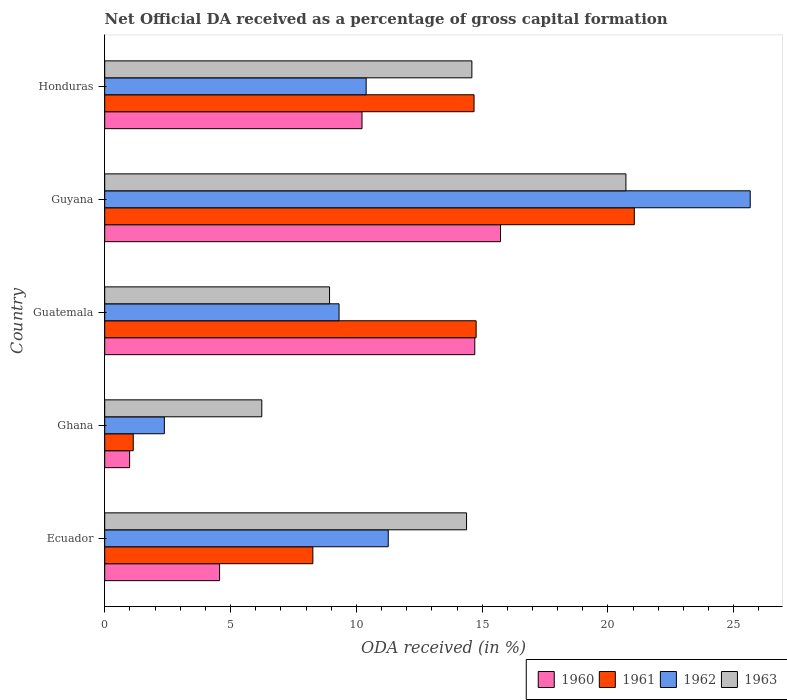How many different coloured bars are there?
Provide a short and direct response. 4. How many groups of bars are there?
Offer a very short reply. 5. Are the number of bars on each tick of the Y-axis equal?
Give a very brief answer. Yes. What is the label of the 3rd group of bars from the top?
Ensure brevity in your answer.  Guatemala. What is the net ODA received in 1961 in Ghana?
Offer a terse response. 1.13. Across all countries, what is the maximum net ODA received in 1962?
Offer a terse response. 25.65. Across all countries, what is the minimum net ODA received in 1961?
Ensure brevity in your answer.  1.13. In which country was the net ODA received in 1961 maximum?
Keep it short and to the point. Guyana. What is the total net ODA received in 1961 in the graph?
Keep it short and to the point. 59.89. What is the difference between the net ODA received in 1962 in Guatemala and that in Guyana?
Offer a terse response. -16.34. What is the difference between the net ODA received in 1963 in Guyana and the net ODA received in 1962 in Guatemala?
Your answer should be compact. 11.4. What is the average net ODA received in 1961 per country?
Offer a very short reply. 11.98. What is the difference between the net ODA received in 1963 and net ODA received in 1961 in Guatemala?
Keep it short and to the point. -5.83. What is the ratio of the net ODA received in 1960 in Ecuador to that in Ghana?
Your answer should be compact. 4.61. Is the net ODA received in 1960 in Ghana less than that in Guatemala?
Your answer should be compact. Yes. What is the difference between the highest and the second highest net ODA received in 1962?
Ensure brevity in your answer.  14.39. What is the difference between the highest and the lowest net ODA received in 1961?
Your response must be concise. 19.91. In how many countries, is the net ODA received in 1963 greater than the average net ODA received in 1963 taken over all countries?
Ensure brevity in your answer.  3. Is it the case that in every country, the sum of the net ODA received in 1963 and net ODA received in 1962 is greater than the sum of net ODA received in 1960 and net ODA received in 1961?
Provide a short and direct response. No. What does the 4th bar from the top in Ghana represents?
Offer a terse response. 1960. What does the 2nd bar from the bottom in Honduras represents?
Provide a succinct answer. 1961. Is it the case that in every country, the sum of the net ODA received in 1962 and net ODA received in 1960 is greater than the net ODA received in 1961?
Give a very brief answer. Yes. How many bars are there?
Make the answer very short. 20. Are all the bars in the graph horizontal?
Make the answer very short. Yes. What is the difference between two consecutive major ticks on the X-axis?
Keep it short and to the point. 5. How many legend labels are there?
Provide a short and direct response. 4. How are the legend labels stacked?
Your answer should be very brief. Horizontal. What is the title of the graph?
Offer a very short reply. Net Official DA received as a percentage of gross capital formation. Does "1988" appear as one of the legend labels in the graph?
Your response must be concise. No. What is the label or title of the X-axis?
Offer a terse response. ODA received (in %). What is the label or title of the Y-axis?
Your answer should be compact. Country. What is the ODA received (in %) in 1960 in Ecuador?
Make the answer very short. 4.56. What is the ODA received (in %) in 1961 in Ecuador?
Provide a short and direct response. 8.27. What is the ODA received (in %) in 1962 in Ecuador?
Your answer should be very brief. 11.27. What is the ODA received (in %) of 1963 in Ecuador?
Offer a terse response. 14.38. What is the ODA received (in %) in 1960 in Ghana?
Provide a succinct answer. 0.99. What is the ODA received (in %) in 1961 in Ghana?
Your answer should be very brief. 1.13. What is the ODA received (in %) in 1962 in Ghana?
Provide a short and direct response. 2.37. What is the ODA received (in %) of 1963 in Ghana?
Your answer should be compact. 6.24. What is the ODA received (in %) in 1960 in Guatemala?
Your answer should be compact. 14.71. What is the ODA received (in %) of 1961 in Guatemala?
Give a very brief answer. 14.76. What is the ODA received (in %) of 1962 in Guatemala?
Provide a succinct answer. 9.31. What is the ODA received (in %) in 1963 in Guatemala?
Provide a short and direct response. 8.93. What is the ODA received (in %) in 1960 in Guyana?
Offer a terse response. 15.73. What is the ODA received (in %) of 1961 in Guyana?
Your answer should be very brief. 21.05. What is the ODA received (in %) in 1962 in Guyana?
Your response must be concise. 25.65. What is the ODA received (in %) of 1963 in Guyana?
Provide a succinct answer. 20.71. What is the ODA received (in %) in 1960 in Honduras?
Keep it short and to the point. 10.23. What is the ODA received (in %) in 1961 in Honduras?
Provide a succinct answer. 14.68. What is the ODA received (in %) in 1962 in Honduras?
Offer a terse response. 10.39. What is the ODA received (in %) in 1963 in Honduras?
Provide a short and direct response. 14.59. Across all countries, what is the maximum ODA received (in %) of 1960?
Provide a short and direct response. 15.73. Across all countries, what is the maximum ODA received (in %) of 1961?
Make the answer very short. 21.05. Across all countries, what is the maximum ODA received (in %) of 1962?
Give a very brief answer. 25.65. Across all countries, what is the maximum ODA received (in %) of 1963?
Make the answer very short. 20.71. Across all countries, what is the minimum ODA received (in %) in 1960?
Offer a terse response. 0.99. Across all countries, what is the minimum ODA received (in %) in 1961?
Your answer should be compact. 1.13. Across all countries, what is the minimum ODA received (in %) of 1962?
Provide a short and direct response. 2.37. Across all countries, what is the minimum ODA received (in %) of 1963?
Make the answer very short. 6.24. What is the total ODA received (in %) of 1960 in the graph?
Provide a short and direct response. 46.22. What is the total ODA received (in %) of 1961 in the graph?
Offer a very short reply. 59.89. What is the total ODA received (in %) in 1962 in the graph?
Make the answer very short. 58.99. What is the total ODA received (in %) of 1963 in the graph?
Make the answer very short. 64.86. What is the difference between the ODA received (in %) in 1960 in Ecuador and that in Ghana?
Provide a succinct answer. 3.57. What is the difference between the ODA received (in %) of 1961 in Ecuador and that in Ghana?
Provide a succinct answer. 7.14. What is the difference between the ODA received (in %) of 1962 in Ecuador and that in Ghana?
Make the answer very short. 8.9. What is the difference between the ODA received (in %) of 1963 in Ecuador and that in Ghana?
Offer a very short reply. 8.14. What is the difference between the ODA received (in %) in 1960 in Ecuador and that in Guatemala?
Give a very brief answer. -10.14. What is the difference between the ODA received (in %) of 1961 in Ecuador and that in Guatemala?
Provide a short and direct response. -6.49. What is the difference between the ODA received (in %) in 1962 in Ecuador and that in Guatemala?
Your answer should be very brief. 1.95. What is the difference between the ODA received (in %) of 1963 in Ecuador and that in Guatemala?
Your answer should be compact. 5.44. What is the difference between the ODA received (in %) of 1960 in Ecuador and that in Guyana?
Your response must be concise. -11.17. What is the difference between the ODA received (in %) in 1961 in Ecuador and that in Guyana?
Ensure brevity in your answer.  -12.78. What is the difference between the ODA received (in %) in 1962 in Ecuador and that in Guyana?
Keep it short and to the point. -14.39. What is the difference between the ODA received (in %) of 1963 in Ecuador and that in Guyana?
Your answer should be very brief. -6.33. What is the difference between the ODA received (in %) in 1960 in Ecuador and that in Honduras?
Ensure brevity in your answer.  -5.66. What is the difference between the ODA received (in %) in 1961 in Ecuador and that in Honduras?
Ensure brevity in your answer.  -6.41. What is the difference between the ODA received (in %) in 1962 in Ecuador and that in Honduras?
Give a very brief answer. 0.88. What is the difference between the ODA received (in %) of 1963 in Ecuador and that in Honduras?
Offer a very short reply. -0.21. What is the difference between the ODA received (in %) in 1960 in Ghana and that in Guatemala?
Provide a succinct answer. -13.72. What is the difference between the ODA received (in %) of 1961 in Ghana and that in Guatemala?
Provide a short and direct response. -13.63. What is the difference between the ODA received (in %) in 1962 in Ghana and that in Guatemala?
Provide a succinct answer. -6.94. What is the difference between the ODA received (in %) in 1963 in Ghana and that in Guatemala?
Give a very brief answer. -2.69. What is the difference between the ODA received (in %) in 1960 in Ghana and that in Guyana?
Ensure brevity in your answer.  -14.74. What is the difference between the ODA received (in %) in 1961 in Ghana and that in Guyana?
Make the answer very short. -19.91. What is the difference between the ODA received (in %) in 1962 in Ghana and that in Guyana?
Offer a very short reply. -23.28. What is the difference between the ODA received (in %) in 1963 in Ghana and that in Guyana?
Your answer should be very brief. -14.47. What is the difference between the ODA received (in %) in 1960 in Ghana and that in Honduras?
Offer a very short reply. -9.23. What is the difference between the ODA received (in %) in 1961 in Ghana and that in Honduras?
Your answer should be compact. -13.54. What is the difference between the ODA received (in %) of 1962 in Ghana and that in Honduras?
Your response must be concise. -8.02. What is the difference between the ODA received (in %) of 1963 in Ghana and that in Honduras?
Ensure brevity in your answer.  -8.35. What is the difference between the ODA received (in %) of 1960 in Guatemala and that in Guyana?
Offer a very short reply. -1.02. What is the difference between the ODA received (in %) in 1961 in Guatemala and that in Guyana?
Offer a terse response. -6.29. What is the difference between the ODA received (in %) in 1962 in Guatemala and that in Guyana?
Offer a very short reply. -16.34. What is the difference between the ODA received (in %) in 1963 in Guatemala and that in Guyana?
Your response must be concise. -11.78. What is the difference between the ODA received (in %) of 1960 in Guatemala and that in Honduras?
Your answer should be very brief. 4.48. What is the difference between the ODA received (in %) in 1961 in Guatemala and that in Honduras?
Make the answer very short. 0.08. What is the difference between the ODA received (in %) of 1962 in Guatemala and that in Honduras?
Ensure brevity in your answer.  -1.08. What is the difference between the ODA received (in %) of 1963 in Guatemala and that in Honduras?
Make the answer very short. -5.66. What is the difference between the ODA received (in %) of 1960 in Guyana and that in Honduras?
Keep it short and to the point. 5.5. What is the difference between the ODA received (in %) of 1961 in Guyana and that in Honduras?
Provide a succinct answer. 6.37. What is the difference between the ODA received (in %) of 1962 in Guyana and that in Honduras?
Provide a succinct answer. 15.26. What is the difference between the ODA received (in %) in 1963 in Guyana and that in Honduras?
Keep it short and to the point. 6.12. What is the difference between the ODA received (in %) in 1960 in Ecuador and the ODA received (in %) in 1961 in Ghana?
Offer a very short reply. 3.43. What is the difference between the ODA received (in %) of 1960 in Ecuador and the ODA received (in %) of 1962 in Ghana?
Your response must be concise. 2.19. What is the difference between the ODA received (in %) of 1960 in Ecuador and the ODA received (in %) of 1963 in Ghana?
Offer a very short reply. -1.68. What is the difference between the ODA received (in %) of 1961 in Ecuador and the ODA received (in %) of 1962 in Ghana?
Offer a very short reply. 5.9. What is the difference between the ODA received (in %) in 1961 in Ecuador and the ODA received (in %) in 1963 in Ghana?
Give a very brief answer. 2.03. What is the difference between the ODA received (in %) of 1962 in Ecuador and the ODA received (in %) of 1963 in Ghana?
Give a very brief answer. 5.03. What is the difference between the ODA received (in %) of 1960 in Ecuador and the ODA received (in %) of 1961 in Guatemala?
Offer a very short reply. -10.2. What is the difference between the ODA received (in %) of 1960 in Ecuador and the ODA received (in %) of 1962 in Guatemala?
Keep it short and to the point. -4.75. What is the difference between the ODA received (in %) of 1960 in Ecuador and the ODA received (in %) of 1963 in Guatemala?
Provide a succinct answer. -4.37. What is the difference between the ODA received (in %) in 1961 in Ecuador and the ODA received (in %) in 1962 in Guatemala?
Offer a terse response. -1.04. What is the difference between the ODA received (in %) of 1961 in Ecuador and the ODA received (in %) of 1963 in Guatemala?
Your response must be concise. -0.66. What is the difference between the ODA received (in %) in 1962 in Ecuador and the ODA received (in %) in 1963 in Guatemala?
Offer a terse response. 2.33. What is the difference between the ODA received (in %) in 1960 in Ecuador and the ODA received (in %) in 1961 in Guyana?
Ensure brevity in your answer.  -16.48. What is the difference between the ODA received (in %) in 1960 in Ecuador and the ODA received (in %) in 1962 in Guyana?
Your answer should be very brief. -21.09. What is the difference between the ODA received (in %) in 1960 in Ecuador and the ODA received (in %) in 1963 in Guyana?
Provide a succinct answer. -16.15. What is the difference between the ODA received (in %) of 1961 in Ecuador and the ODA received (in %) of 1962 in Guyana?
Provide a short and direct response. -17.38. What is the difference between the ODA received (in %) in 1961 in Ecuador and the ODA received (in %) in 1963 in Guyana?
Provide a short and direct response. -12.44. What is the difference between the ODA received (in %) of 1962 in Ecuador and the ODA received (in %) of 1963 in Guyana?
Offer a very short reply. -9.45. What is the difference between the ODA received (in %) of 1960 in Ecuador and the ODA received (in %) of 1961 in Honduras?
Give a very brief answer. -10.11. What is the difference between the ODA received (in %) of 1960 in Ecuador and the ODA received (in %) of 1962 in Honduras?
Ensure brevity in your answer.  -5.83. What is the difference between the ODA received (in %) in 1960 in Ecuador and the ODA received (in %) in 1963 in Honduras?
Ensure brevity in your answer.  -10.03. What is the difference between the ODA received (in %) of 1961 in Ecuador and the ODA received (in %) of 1962 in Honduras?
Your answer should be very brief. -2.12. What is the difference between the ODA received (in %) in 1961 in Ecuador and the ODA received (in %) in 1963 in Honduras?
Ensure brevity in your answer.  -6.32. What is the difference between the ODA received (in %) in 1962 in Ecuador and the ODA received (in %) in 1963 in Honduras?
Your answer should be compact. -3.32. What is the difference between the ODA received (in %) in 1960 in Ghana and the ODA received (in %) in 1961 in Guatemala?
Offer a very short reply. -13.77. What is the difference between the ODA received (in %) of 1960 in Ghana and the ODA received (in %) of 1962 in Guatemala?
Give a very brief answer. -8.32. What is the difference between the ODA received (in %) of 1960 in Ghana and the ODA received (in %) of 1963 in Guatemala?
Provide a succinct answer. -7.94. What is the difference between the ODA received (in %) in 1961 in Ghana and the ODA received (in %) in 1962 in Guatemala?
Your answer should be very brief. -8.18. What is the difference between the ODA received (in %) of 1961 in Ghana and the ODA received (in %) of 1963 in Guatemala?
Offer a very short reply. -7.8. What is the difference between the ODA received (in %) of 1962 in Ghana and the ODA received (in %) of 1963 in Guatemala?
Provide a succinct answer. -6.56. What is the difference between the ODA received (in %) in 1960 in Ghana and the ODA received (in %) in 1961 in Guyana?
Offer a terse response. -20.06. What is the difference between the ODA received (in %) in 1960 in Ghana and the ODA received (in %) in 1962 in Guyana?
Offer a very short reply. -24.66. What is the difference between the ODA received (in %) of 1960 in Ghana and the ODA received (in %) of 1963 in Guyana?
Provide a short and direct response. -19.72. What is the difference between the ODA received (in %) in 1961 in Ghana and the ODA received (in %) in 1962 in Guyana?
Your response must be concise. -24.52. What is the difference between the ODA received (in %) of 1961 in Ghana and the ODA received (in %) of 1963 in Guyana?
Make the answer very short. -19.58. What is the difference between the ODA received (in %) of 1962 in Ghana and the ODA received (in %) of 1963 in Guyana?
Your answer should be compact. -18.34. What is the difference between the ODA received (in %) of 1960 in Ghana and the ODA received (in %) of 1961 in Honduras?
Offer a terse response. -13.69. What is the difference between the ODA received (in %) of 1960 in Ghana and the ODA received (in %) of 1962 in Honduras?
Provide a short and direct response. -9.4. What is the difference between the ODA received (in %) of 1960 in Ghana and the ODA received (in %) of 1963 in Honduras?
Give a very brief answer. -13.6. What is the difference between the ODA received (in %) in 1961 in Ghana and the ODA received (in %) in 1962 in Honduras?
Your response must be concise. -9.26. What is the difference between the ODA received (in %) in 1961 in Ghana and the ODA received (in %) in 1963 in Honduras?
Your response must be concise. -13.46. What is the difference between the ODA received (in %) in 1962 in Ghana and the ODA received (in %) in 1963 in Honduras?
Your answer should be very brief. -12.22. What is the difference between the ODA received (in %) in 1960 in Guatemala and the ODA received (in %) in 1961 in Guyana?
Make the answer very short. -6.34. What is the difference between the ODA received (in %) of 1960 in Guatemala and the ODA received (in %) of 1962 in Guyana?
Your response must be concise. -10.95. What is the difference between the ODA received (in %) of 1960 in Guatemala and the ODA received (in %) of 1963 in Guyana?
Make the answer very short. -6.01. What is the difference between the ODA received (in %) in 1961 in Guatemala and the ODA received (in %) in 1962 in Guyana?
Give a very brief answer. -10.89. What is the difference between the ODA received (in %) in 1961 in Guatemala and the ODA received (in %) in 1963 in Guyana?
Provide a succinct answer. -5.95. What is the difference between the ODA received (in %) of 1962 in Guatemala and the ODA received (in %) of 1963 in Guyana?
Provide a succinct answer. -11.4. What is the difference between the ODA received (in %) in 1960 in Guatemala and the ODA received (in %) in 1961 in Honduras?
Offer a very short reply. 0.03. What is the difference between the ODA received (in %) of 1960 in Guatemala and the ODA received (in %) of 1962 in Honduras?
Offer a very short reply. 4.32. What is the difference between the ODA received (in %) in 1960 in Guatemala and the ODA received (in %) in 1963 in Honduras?
Ensure brevity in your answer.  0.12. What is the difference between the ODA received (in %) of 1961 in Guatemala and the ODA received (in %) of 1962 in Honduras?
Provide a short and direct response. 4.37. What is the difference between the ODA received (in %) in 1961 in Guatemala and the ODA received (in %) in 1963 in Honduras?
Ensure brevity in your answer.  0.17. What is the difference between the ODA received (in %) of 1962 in Guatemala and the ODA received (in %) of 1963 in Honduras?
Make the answer very short. -5.28. What is the difference between the ODA received (in %) of 1960 in Guyana and the ODA received (in %) of 1961 in Honduras?
Make the answer very short. 1.05. What is the difference between the ODA received (in %) of 1960 in Guyana and the ODA received (in %) of 1962 in Honduras?
Provide a succinct answer. 5.34. What is the difference between the ODA received (in %) in 1960 in Guyana and the ODA received (in %) in 1963 in Honduras?
Ensure brevity in your answer.  1.14. What is the difference between the ODA received (in %) in 1961 in Guyana and the ODA received (in %) in 1962 in Honduras?
Give a very brief answer. 10.66. What is the difference between the ODA received (in %) in 1961 in Guyana and the ODA received (in %) in 1963 in Honduras?
Give a very brief answer. 6.46. What is the difference between the ODA received (in %) in 1962 in Guyana and the ODA received (in %) in 1963 in Honduras?
Give a very brief answer. 11.06. What is the average ODA received (in %) of 1960 per country?
Offer a terse response. 9.24. What is the average ODA received (in %) in 1961 per country?
Your response must be concise. 11.98. What is the average ODA received (in %) of 1962 per country?
Your answer should be very brief. 11.8. What is the average ODA received (in %) in 1963 per country?
Keep it short and to the point. 12.97. What is the difference between the ODA received (in %) of 1960 and ODA received (in %) of 1961 in Ecuador?
Provide a succinct answer. -3.71. What is the difference between the ODA received (in %) in 1960 and ODA received (in %) in 1962 in Ecuador?
Offer a terse response. -6.7. What is the difference between the ODA received (in %) of 1960 and ODA received (in %) of 1963 in Ecuador?
Your answer should be very brief. -9.81. What is the difference between the ODA received (in %) of 1961 and ODA received (in %) of 1962 in Ecuador?
Make the answer very short. -3. What is the difference between the ODA received (in %) in 1961 and ODA received (in %) in 1963 in Ecuador?
Provide a succinct answer. -6.11. What is the difference between the ODA received (in %) of 1962 and ODA received (in %) of 1963 in Ecuador?
Provide a succinct answer. -3.11. What is the difference between the ODA received (in %) of 1960 and ODA received (in %) of 1961 in Ghana?
Your answer should be compact. -0.14. What is the difference between the ODA received (in %) of 1960 and ODA received (in %) of 1962 in Ghana?
Provide a short and direct response. -1.38. What is the difference between the ODA received (in %) in 1960 and ODA received (in %) in 1963 in Ghana?
Give a very brief answer. -5.25. What is the difference between the ODA received (in %) of 1961 and ODA received (in %) of 1962 in Ghana?
Keep it short and to the point. -1.24. What is the difference between the ODA received (in %) of 1961 and ODA received (in %) of 1963 in Ghana?
Offer a very short reply. -5.11. What is the difference between the ODA received (in %) in 1962 and ODA received (in %) in 1963 in Ghana?
Keep it short and to the point. -3.87. What is the difference between the ODA received (in %) of 1960 and ODA received (in %) of 1961 in Guatemala?
Offer a terse response. -0.05. What is the difference between the ODA received (in %) of 1960 and ODA received (in %) of 1962 in Guatemala?
Keep it short and to the point. 5.39. What is the difference between the ODA received (in %) in 1960 and ODA received (in %) in 1963 in Guatemala?
Your response must be concise. 5.77. What is the difference between the ODA received (in %) in 1961 and ODA received (in %) in 1962 in Guatemala?
Keep it short and to the point. 5.45. What is the difference between the ODA received (in %) in 1961 and ODA received (in %) in 1963 in Guatemala?
Ensure brevity in your answer.  5.83. What is the difference between the ODA received (in %) of 1962 and ODA received (in %) of 1963 in Guatemala?
Give a very brief answer. 0.38. What is the difference between the ODA received (in %) of 1960 and ODA received (in %) of 1961 in Guyana?
Provide a short and direct response. -5.32. What is the difference between the ODA received (in %) of 1960 and ODA received (in %) of 1962 in Guyana?
Keep it short and to the point. -9.92. What is the difference between the ODA received (in %) in 1960 and ODA received (in %) in 1963 in Guyana?
Offer a very short reply. -4.98. What is the difference between the ODA received (in %) of 1961 and ODA received (in %) of 1962 in Guyana?
Your answer should be very brief. -4.61. What is the difference between the ODA received (in %) in 1961 and ODA received (in %) in 1963 in Guyana?
Provide a succinct answer. 0.33. What is the difference between the ODA received (in %) of 1962 and ODA received (in %) of 1963 in Guyana?
Give a very brief answer. 4.94. What is the difference between the ODA received (in %) of 1960 and ODA received (in %) of 1961 in Honduras?
Your answer should be compact. -4.45. What is the difference between the ODA received (in %) in 1960 and ODA received (in %) in 1962 in Honduras?
Keep it short and to the point. -0.16. What is the difference between the ODA received (in %) of 1960 and ODA received (in %) of 1963 in Honduras?
Your answer should be compact. -4.37. What is the difference between the ODA received (in %) in 1961 and ODA received (in %) in 1962 in Honduras?
Make the answer very short. 4.29. What is the difference between the ODA received (in %) of 1961 and ODA received (in %) of 1963 in Honduras?
Give a very brief answer. 0.09. What is the difference between the ODA received (in %) of 1962 and ODA received (in %) of 1963 in Honduras?
Your response must be concise. -4.2. What is the ratio of the ODA received (in %) of 1960 in Ecuador to that in Ghana?
Your answer should be very brief. 4.61. What is the ratio of the ODA received (in %) in 1961 in Ecuador to that in Ghana?
Your response must be concise. 7.3. What is the ratio of the ODA received (in %) of 1962 in Ecuador to that in Ghana?
Offer a terse response. 4.75. What is the ratio of the ODA received (in %) of 1963 in Ecuador to that in Ghana?
Your response must be concise. 2.3. What is the ratio of the ODA received (in %) in 1960 in Ecuador to that in Guatemala?
Offer a very short reply. 0.31. What is the ratio of the ODA received (in %) in 1961 in Ecuador to that in Guatemala?
Ensure brevity in your answer.  0.56. What is the ratio of the ODA received (in %) of 1962 in Ecuador to that in Guatemala?
Offer a terse response. 1.21. What is the ratio of the ODA received (in %) in 1963 in Ecuador to that in Guatemala?
Your response must be concise. 1.61. What is the ratio of the ODA received (in %) of 1960 in Ecuador to that in Guyana?
Make the answer very short. 0.29. What is the ratio of the ODA received (in %) of 1961 in Ecuador to that in Guyana?
Your response must be concise. 0.39. What is the ratio of the ODA received (in %) in 1962 in Ecuador to that in Guyana?
Provide a succinct answer. 0.44. What is the ratio of the ODA received (in %) of 1963 in Ecuador to that in Guyana?
Make the answer very short. 0.69. What is the ratio of the ODA received (in %) in 1960 in Ecuador to that in Honduras?
Provide a short and direct response. 0.45. What is the ratio of the ODA received (in %) of 1961 in Ecuador to that in Honduras?
Provide a succinct answer. 0.56. What is the ratio of the ODA received (in %) of 1962 in Ecuador to that in Honduras?
Your answer should be very brief. 1.08. What is the ratio of the ODA received (in %) in 1963 in Ecuador to that in Honduras?
Provide a short and direct response. 0.99. What is the ratio of the ODA received (in %) of 1960 in Ghana to that in Guatemala?
Provide a succinct answer. 0.07. What is the ratio of the ODA received (in %) in 1961 in Ghana to that in Guatemala?
Your response must be concise. 0.08. What is the ratio of the ODA received (in %) of 1962 in Ghana to that in Guatemala?
Ensure brevity in your answer.  0.25. What is the ratio of the ODA received (in %) in 1963 in Ghana to that in Guatemala?
Your response must be concise. 0.7. What is the ratio of the ODA received (in %) in 1960 in Ghana to that in Guyana?
Your answer should be compact. 0.06. What is the ratio of the ODA received (in %) of 1961 in Ghana to that in Guyana?
Provide a short and direct response. 0.05. What is the ratio of the ODA received (in %) in 1962 in Ghana to that in Guyana?
Ensure brevity in your answer.  0.09. What is the ratio of the ODA received (in %) of 1963 in Ghana to that in Guyana?
Give a very brief answer. 0.3. What is the ratio of the ODA received (in %) of 1960 in Ghana to that in Honduras?
Make the answer very short. 0.1. What is the ratio of the ODA received (in %) in 1961 in Ghana to that in Honduras?
Offer a very short reply. 0.08. What is the ratio of the ODA received (in %) in 1962 in Ghana to that in Honduras?
Ensure brevity in your answer.  0.23. What is the ratio of the ODA received (in %) in 1963 in Ghana to that in Honduras?
Ensure brevity in your answer.  0.43. What is the ratio of the ODA received (in %) in 1960 in Guatemala to that in Guyana?
Ensure brevity in your answer.  0.94. What is the ratio of the ODA received (in %) of 1961 in Guatemala to that in Guyana?
Make the answer very short. 0.7. What is the ratio of the ODA received (in %) of 1962 in Guatemala to that in Guyana?
Ensure brevity in your answer.  0.36. What is the ratio of the ODA received (in %) in 1963 in Guatemala to that in Guyana?
Your answer should be very brief. 0.43. What is the ratio of the ODA received (in %) of 1960 in Guatemala to that in Honduras?
Keep it short and to the point. 1.44. What is the ratio of the ODA received (in %) in 1962 in Guatemala to that in Honduras?
Provide a short and direct response. 0.9. What is the ratio of the ODA received (in %) of 1963 in Guatemala to that in Honduras?
Keep it short and to the point. 0.61. What is the ratio of the ODA received (in %) in 1960 in Guyana to that in Honduras?
Provide a short and direct response. 1.54. What is the ratio of the ODA received (in %) of 1961 in Guyana to that in Honduras?
Make the answer very short. 1.43. What is the ratio of the ODA received (in %) in 1962 in Guyana to that in Honduras?
Your response must be concise. 2.47. What is the ratio of the ODA received (in %) in 1963 in Guyana to that in Honduras?
Provide a succinct answer. 1.42. What is the difference between the highest and the second highest ODA received (in %) in 1960?
Offer a very short reply. 1.02. What is the difference between the highest and the second highest ODA received (in %) in 1961?
Your answer should be compact. 6.29. What is the difference between the highest and the second highest ODA received (in %) in 1962?
Make the answer very short. 14.39. What is the difference between the highest and the second highest ODA received (in %) of 1963?
Your response must be concise. 6.12. What is the difference between the highest and the lowest ODA received (in %) in 1960?
Give a very brief answer. 14.74. What is the difference between the highest and the lowest ODA received (in %) of 1961?
Offer a very short reply. 19.91. What is the difference between the highest and the lowest ODA received (in %) of 1962?
Provide a succinct answer. 23.28. What is the difference between the highest and the lowest ODA received (in %) in 1963?
Give a very brief answer. 14.47. 